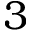Convert formula to latex. <formula><loc_0><loc_0><loc_500><loc_500>3</formula> 